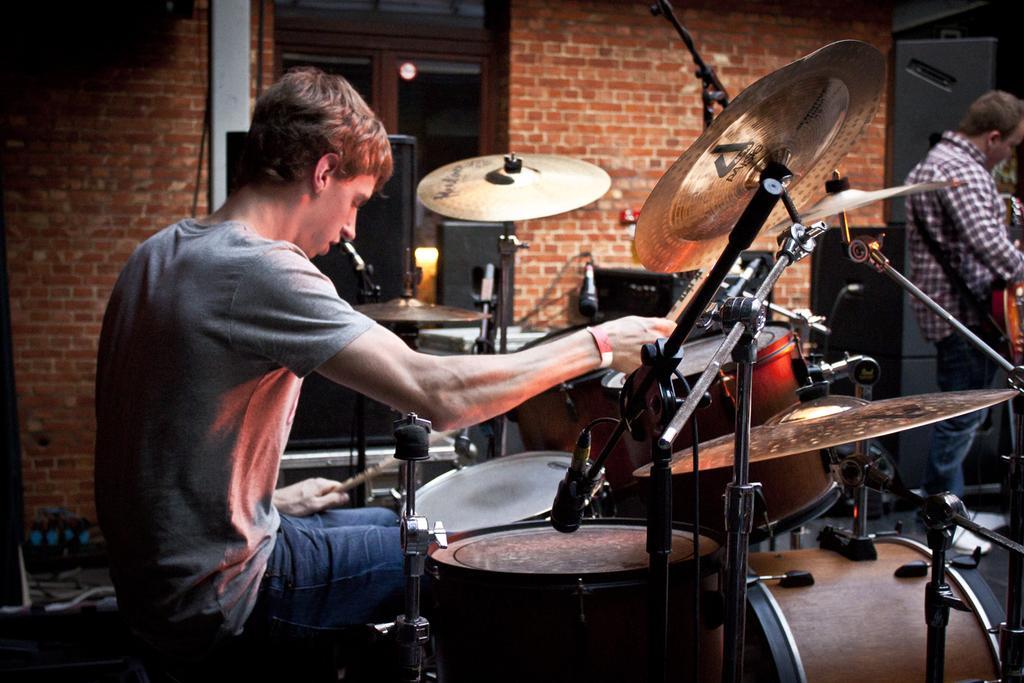In one or two sentences, can you explain what this image depicts? In the center we can see one man sitting on the chair and holding sticks. On the right we can see one man standing and holding guitar. In between them they were few musical instruments. In the background there is a brick wall,door and light. 